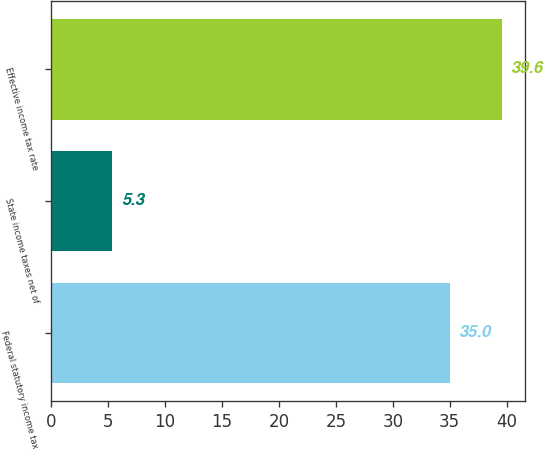Convert chart to OTSL. <chart><loc_0><loc_0><loc_500><loc_500><bar_chart><fcel>Federal statutory income tax<fcel>State income taxes net of<fcel>Effective income tax rate<nl><fcel>35<fcel>5.3<fcel>39.6<nl></chart> 